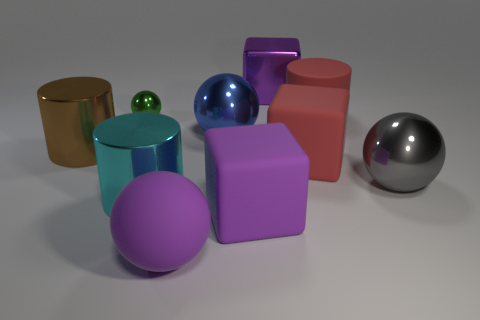How many other things are the same color as the big metallic block? Including the large metallic block, there are three objects with a similar silver-metallic color in the image: the block itself, a small sphere, and a larger sphere. 